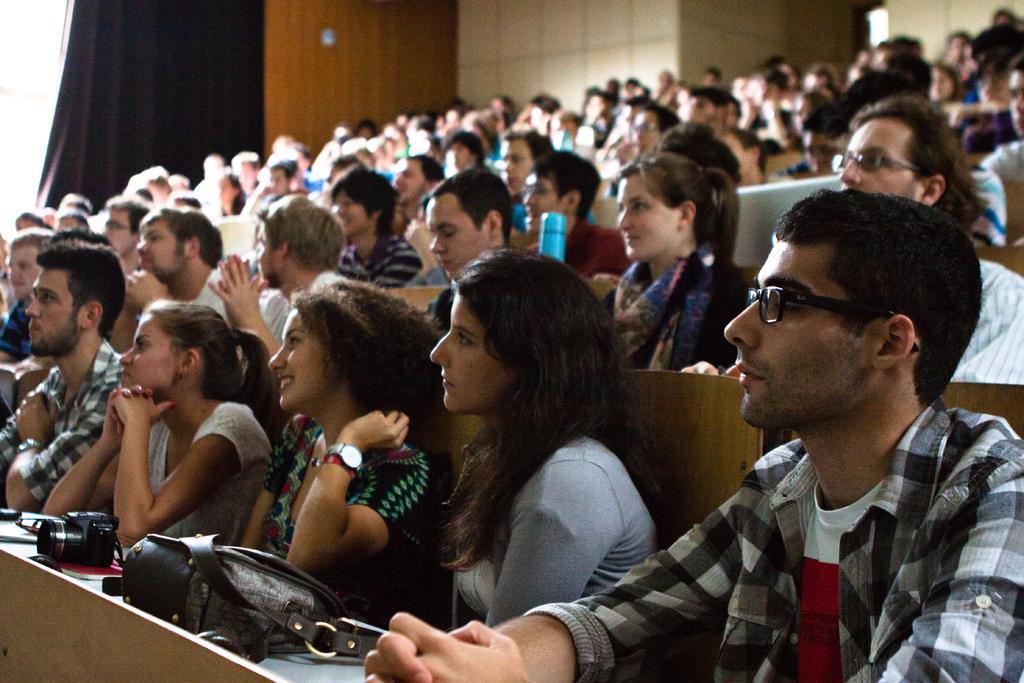Could you give a brief overview of what you see in this image? In this picture we can see some people are sitting in front of desks, at the left bottom we can see a camera and a bag, a man on the right side wore spectacles, in the background we can see a curtain. 